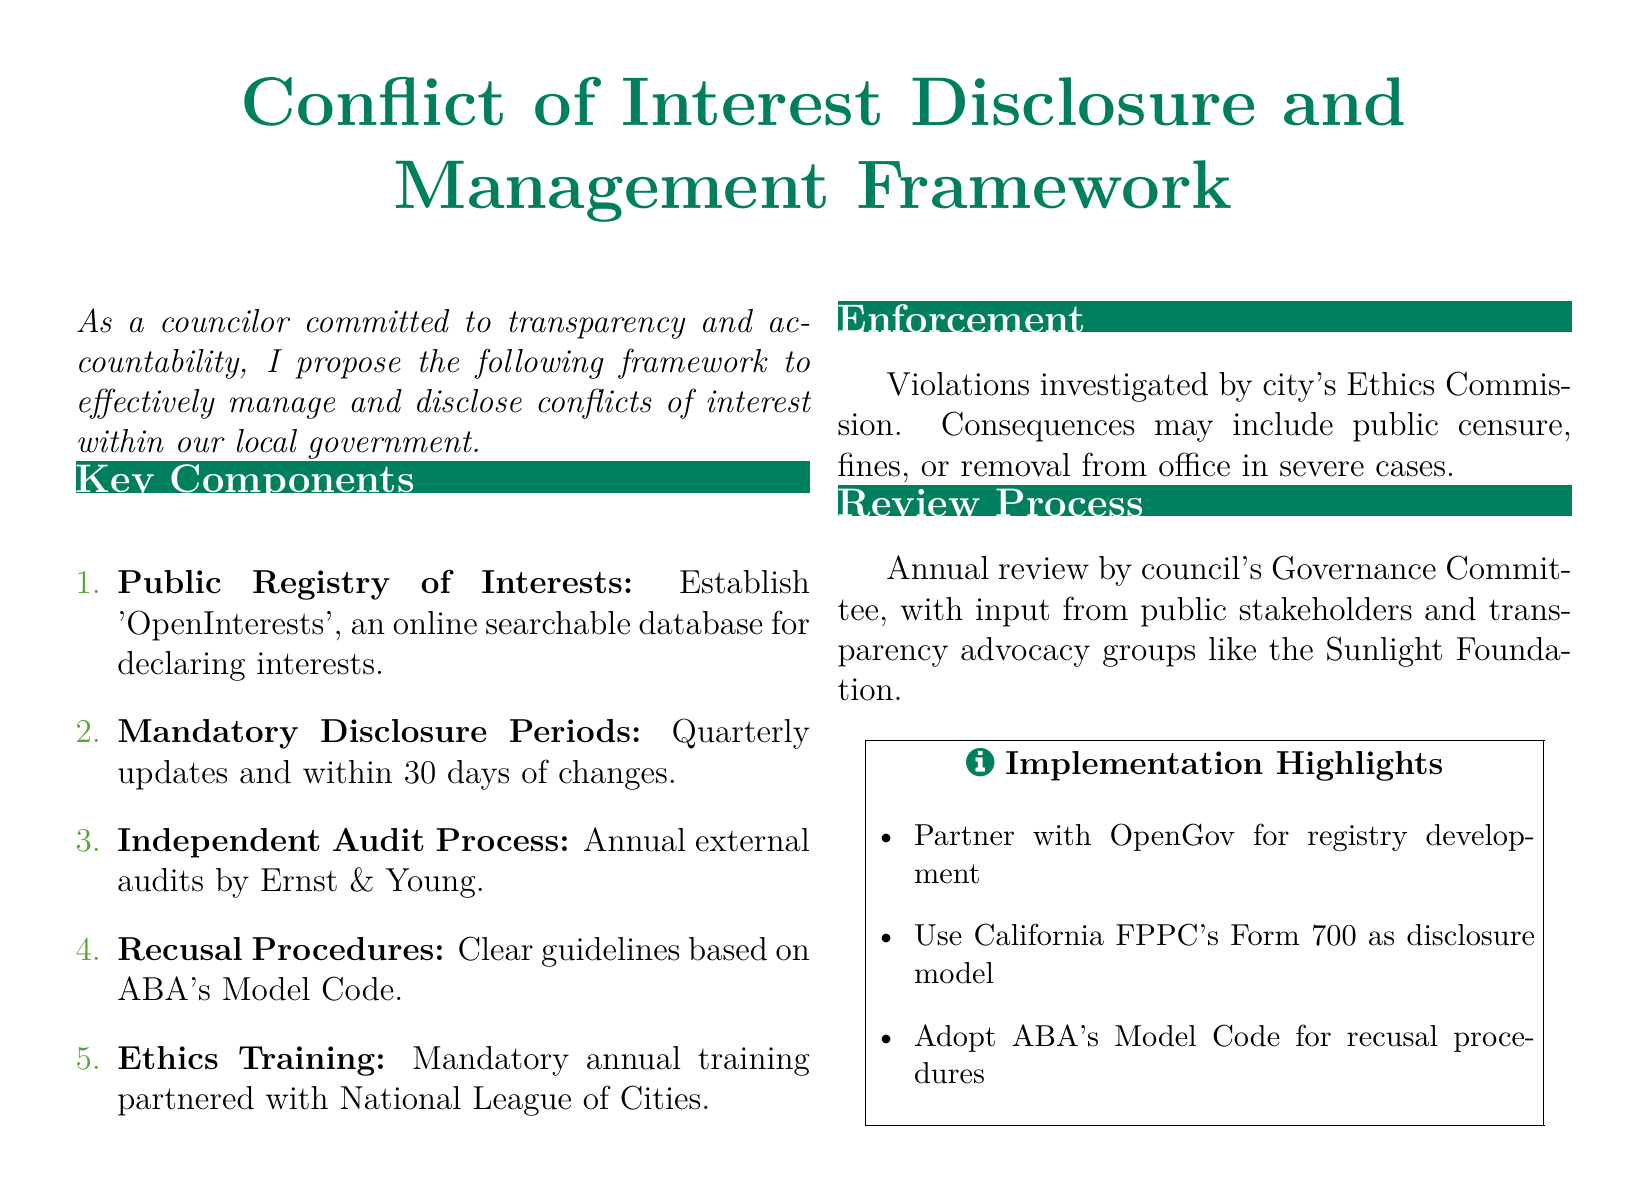What is the name of the online database for declaring interests? The document mentions 'OpenInterests' as the online searchable database for declaring interests.
Answer: OpenInterests How often are mandatory disclosure updates required? According to the document, mandatory disclosure updates are required quarterly.
Answer: Quarterly Who conducts the independent audits of the conflict of interest disclosures? The document states that annual external audits will be conducted by Ernst & Young.
Answer: Ernst & Young What kind of training is mandated annually? The framework requires mandatory annual ethics training in partnership with the National League of Cities.
Answer: Ethics training Which organization investigates violations? The document specifies that violations will be investigated by the city's Ethics Commission.
Answer: Ethics Commission What is the model code referred to for recusal procedures? The document refers to the ABA's Model Code as the guideline for recusal procedures.
Answer: ABA's Model Code What is the purpose of the Governance Committee in the review process? The Governance Committee is tasked with conducting an annual review with input from public stakeholders and transparency advocacy groups.
Answer: Annual review What may be a consequence of severe violations? The document outlines that severe violations may lead to removal from office as a consequence.
Answer: Removal from office 